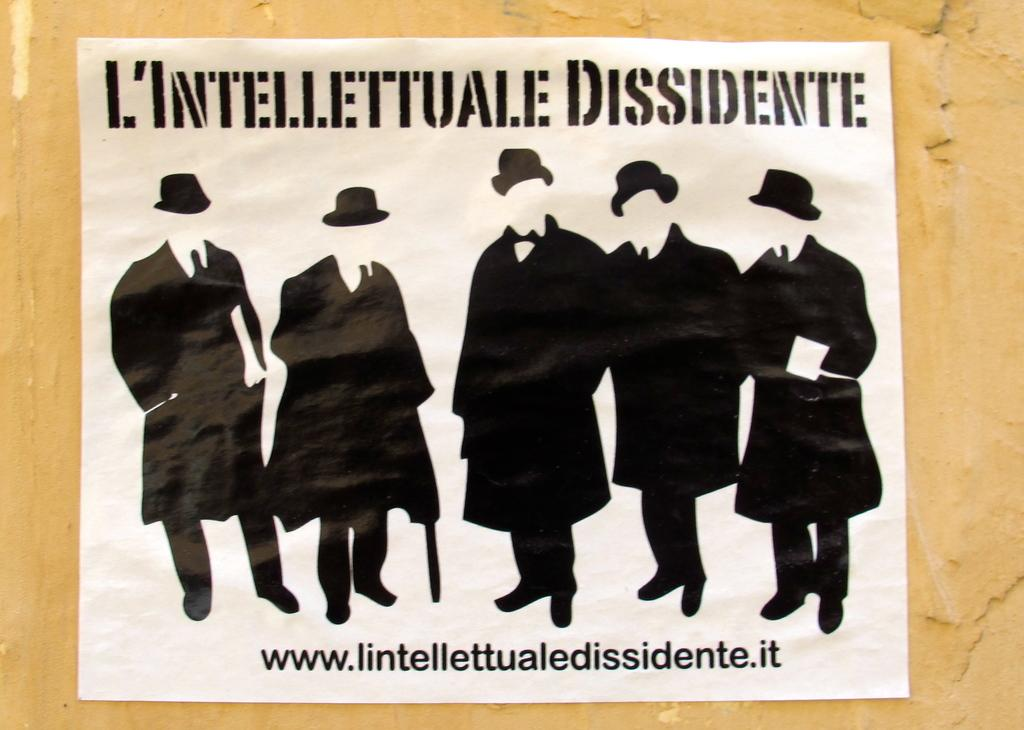What can be seen in the background of the image? There is a wall in the image. What is attached to the wall in the image? There is a poster in the image. What type of content is on the poster? The poster contains text and images. What type of beast is depicted on the poster in the image? There is no beast depicted on the poster in the image; it contains text and images, but none of them are of a beast. 